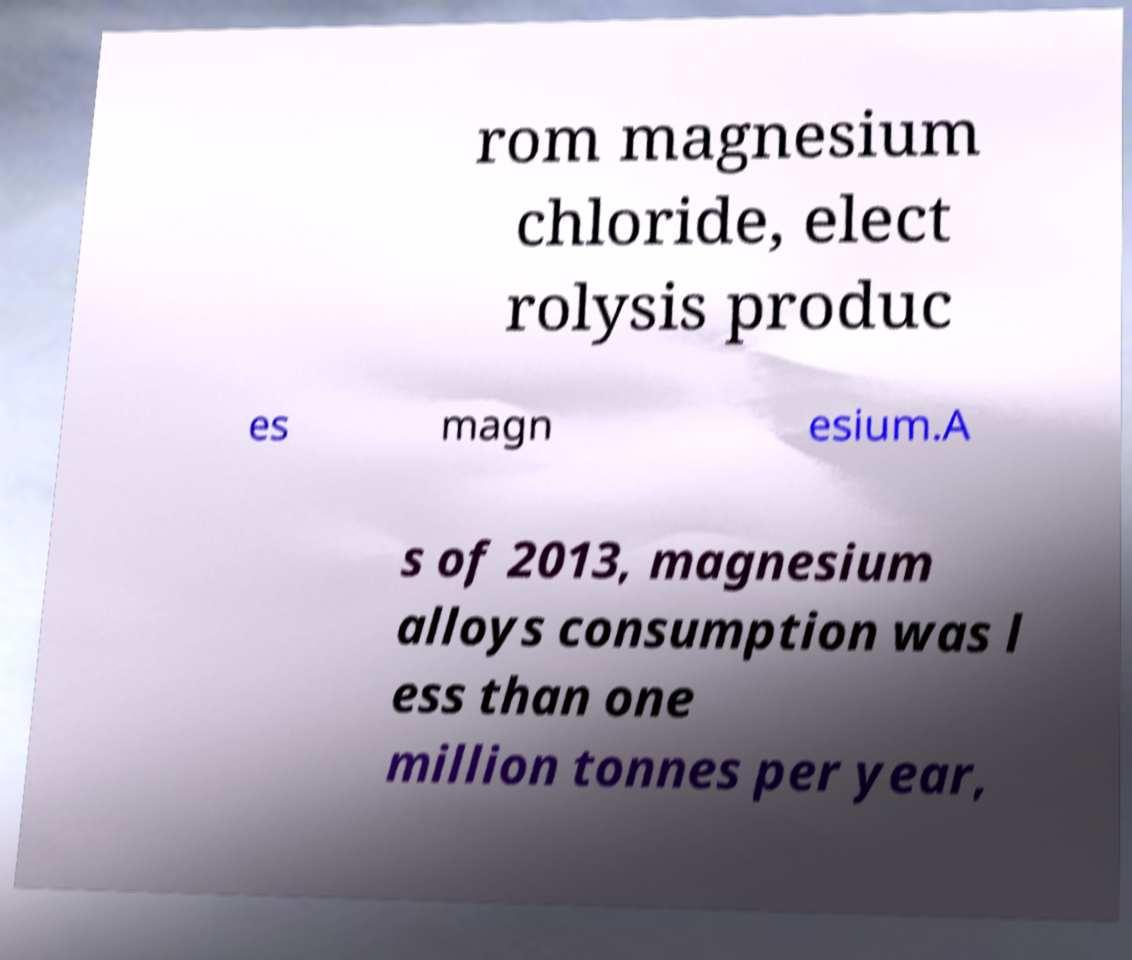I need the written content from this picture converted into text. Can you do that? rom magnesium chloride, elect rolysis produc es magn esium.A s of 2013, magnesium alloys consumption was l ess than one million tonnes per year, 